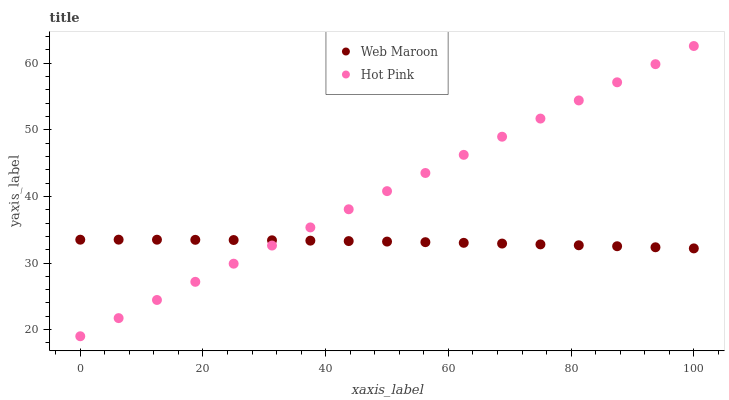Does Web Maroon have the minimum area under the curve?
Answer yes or no. Yes. Does Hot Pink have the maximum area under the curve?
Answer yes or no. Yes. Does Web Maroon have the maximum area under the curve?
Answer yes or no. No. Is Hot Pink the smoothest?
Answer yes or no. Yes. Is Web Maroon the roughest?
Answer yes or no. Yes. Is Web Maroon the smoothest?
Answer yes or no. No. Does Hot Pink have the lowest value?
Answer yes or no. Yes. Does Web Maroon have the lowest value?
Answer yes or no. No. Does Hot Pink have the highest value?
Answer yes or no. Yes. Does Web Maroon have the highest value?
Answer yes or no. No. Does Hot Pink intersect Web Maroon?
Answer yes or no. Yes. Is Hot Pink less than Web Maroon?
Answer yes or no. No. Is Hot Pink greater than Web Maroon?
Answer yes or no. No. 